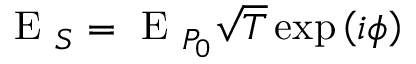<formula> <loc_0><loc_0><loc_500><loc_500>E _ { S } = E _ { P _ { 0 } } \sqrt { T } \exp \left ( i \phi \right )</formula> 